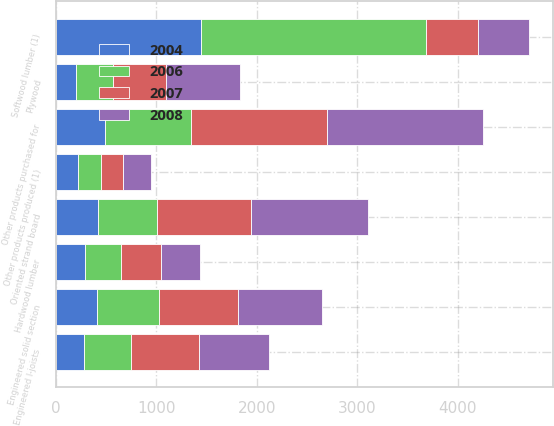Convert chart. <chart><loc_0><loc_0><loc_500><loc_500><stacked_bar_chart><ecel><fcel>Softwood lumber (1)<fcel>Engineered solid section<fcel>Engineered I-joists<fcel>Oriented strand board<fcel>Plywood<fcel>Hardwood lumber<fcel>Other products produced (1)<fcel>Other products purchased for<nl><fcel>2004<fcel>1443<fcel>414<fcel>284<fcel>416<fcel>202<fcel>291<fcel>225<fcel>493<nl><fcel>2006<fcel>2241<fcel>608<fcel>467<fcel>589<fcel>366<fcel>355<fcel>226<fcel>847<nl><fcel>2007<fcel>511<fcel>794<fcel>670<fcel>939<fcel>529<fcel>398<fcel>214<fcel>1361<nl><fcel>2008<fcel>511<fcel>833<fcel>704<fcel>1164<fcel>735<fcel>390<fcel>277<fcel>1551<nl></chart> 